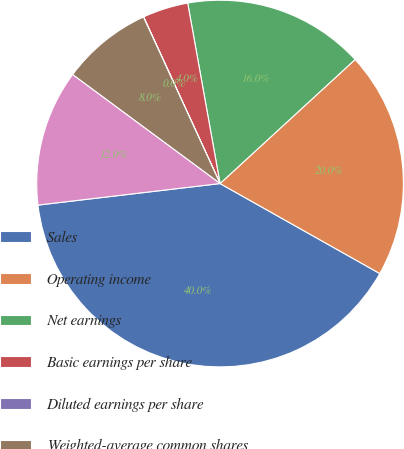Convert chart to OTSL. <chart><loc_0><loc_0><loc_500><loc_500><pie_chart><fcel>Sales<fcel>Operating income<fcel>Net earnings<fcel>Basic earnings per share<fcel>Diluted earnings per share<fcel>Weighted-average common shares<fcel>Weighted-average diluted<nl><fcel>39.96%<fcel>19.99%<fcel>16.0%<fcel>4.02%<fcel>0.02%<fcel>8.01%<fcel>12.0%<nl></chart> 